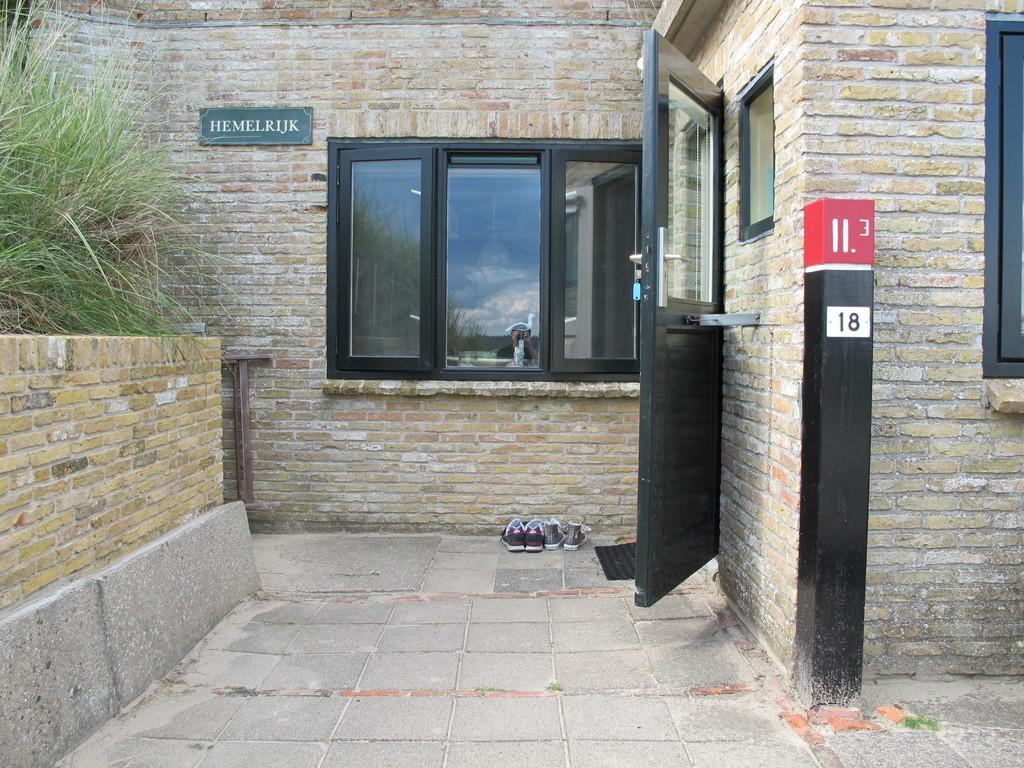Could you give a brief overview of what you see in this image? In this image there is a building , there are windows, door, pole, mat, shoes, name board , grass, wall and there is reflection of a person and sky. 